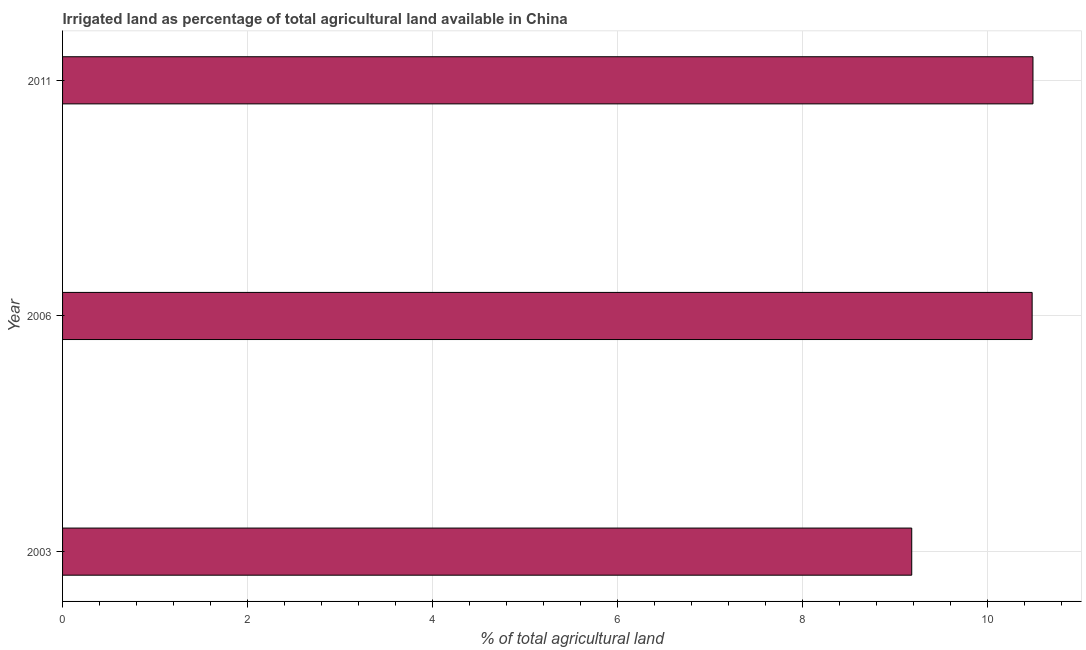Does the graph contain grids?
Ensure brevity in your answer.  Yes. What is the title of the graph?
Give a very brief answer. Irrigated land as percentage of total agricultural land available in China. What is the label or title of the X-axis?
Your response must be concise. % of total agricultural land. What is the percentage of agricultural irrigated land in 2006?
Your response must be concise. 10.48. Across all years, what is the maximum percentage of agricultural irrigated land?
Ensure brevity in your answer.  10.49. Across all years, what is the minimum percentage of agricultural irrigated land?
Provide a succinct answer. 9.18. In which year was the percentage of agricultural irrigated land maximum?
Your answer should be very brief. 2011. In which year was the percentage of agricultural irrigated land minimum?
Your answer should be compact. 2003. What is the sum of the percentage of agricultural irrigated land?
Your answer should be compact. 30.15. What is the difference between the percentage of agricultural irrigated land in 2003 and 2006?
Keep it short and to the point. -1.3. What is the average percentage of agricultural irrigated land per year?
Make the answer very short. 10.05. What is the median percentage of agricultural irrigated land?
Provide a short and direct response. 10.48. In how many years, is the percentage of agricultural irrigated land greater than 5.2 %?
Provide a succinct answer. 3. What is the ratio of the percentage of agricultural irrigated land in 2003 to that in 2006?
Keep it short and to the point. 0.88. Is the percentage of agricultural irrigated land in 2003 less than that in 2006?
Provide a short and direct response. Yes. What is the difference between the highest and the second highest percentage of agricultural irrigated land?
Offer a terse response. 0.01. What is the difference between the highest and the lowest percentage of agricultural irrigated land?
Ensure brevity in your answer.  1.31. In how many years, is the percentage of agricultural irrigated land greater than the average percentage of agricultural irrigated land taken over all years?
Keep it short and to the point. 2. Are all the bars in the graph horizontal?
Offer a very short reply. Yes. What is the difference between two consecutive major ticks on the X-axis?
Offer a terse response. 2. What is the % of total agricultural land in 2003?
Your answer should be compact. 9.18. What is the % of total agricultural land in 2006?
Give a very brief answer. 10.48. What is the % of total agricultural land in 2011?
Give a very brief answer. 10.49. What is the difference between the % of total agricultural land in 2003 and 2006?
Provide a short and direct response. -1.3. What is the difference between the % of total agricultural land in 2003 and 2011?
Offer a terse response. -1.31. What is the difference between the % of total agricultural land in 2006 and 2011?
Provide a short and direct response. -0.01. What is the ratio of the % of total agricultural land in 2003 to that in 2006?
Provide a short and direct response. 0.88. What is the ratio of the % of total agricultural land in 2003 to that in 2011?
Give a very brief answer. 0.88. 